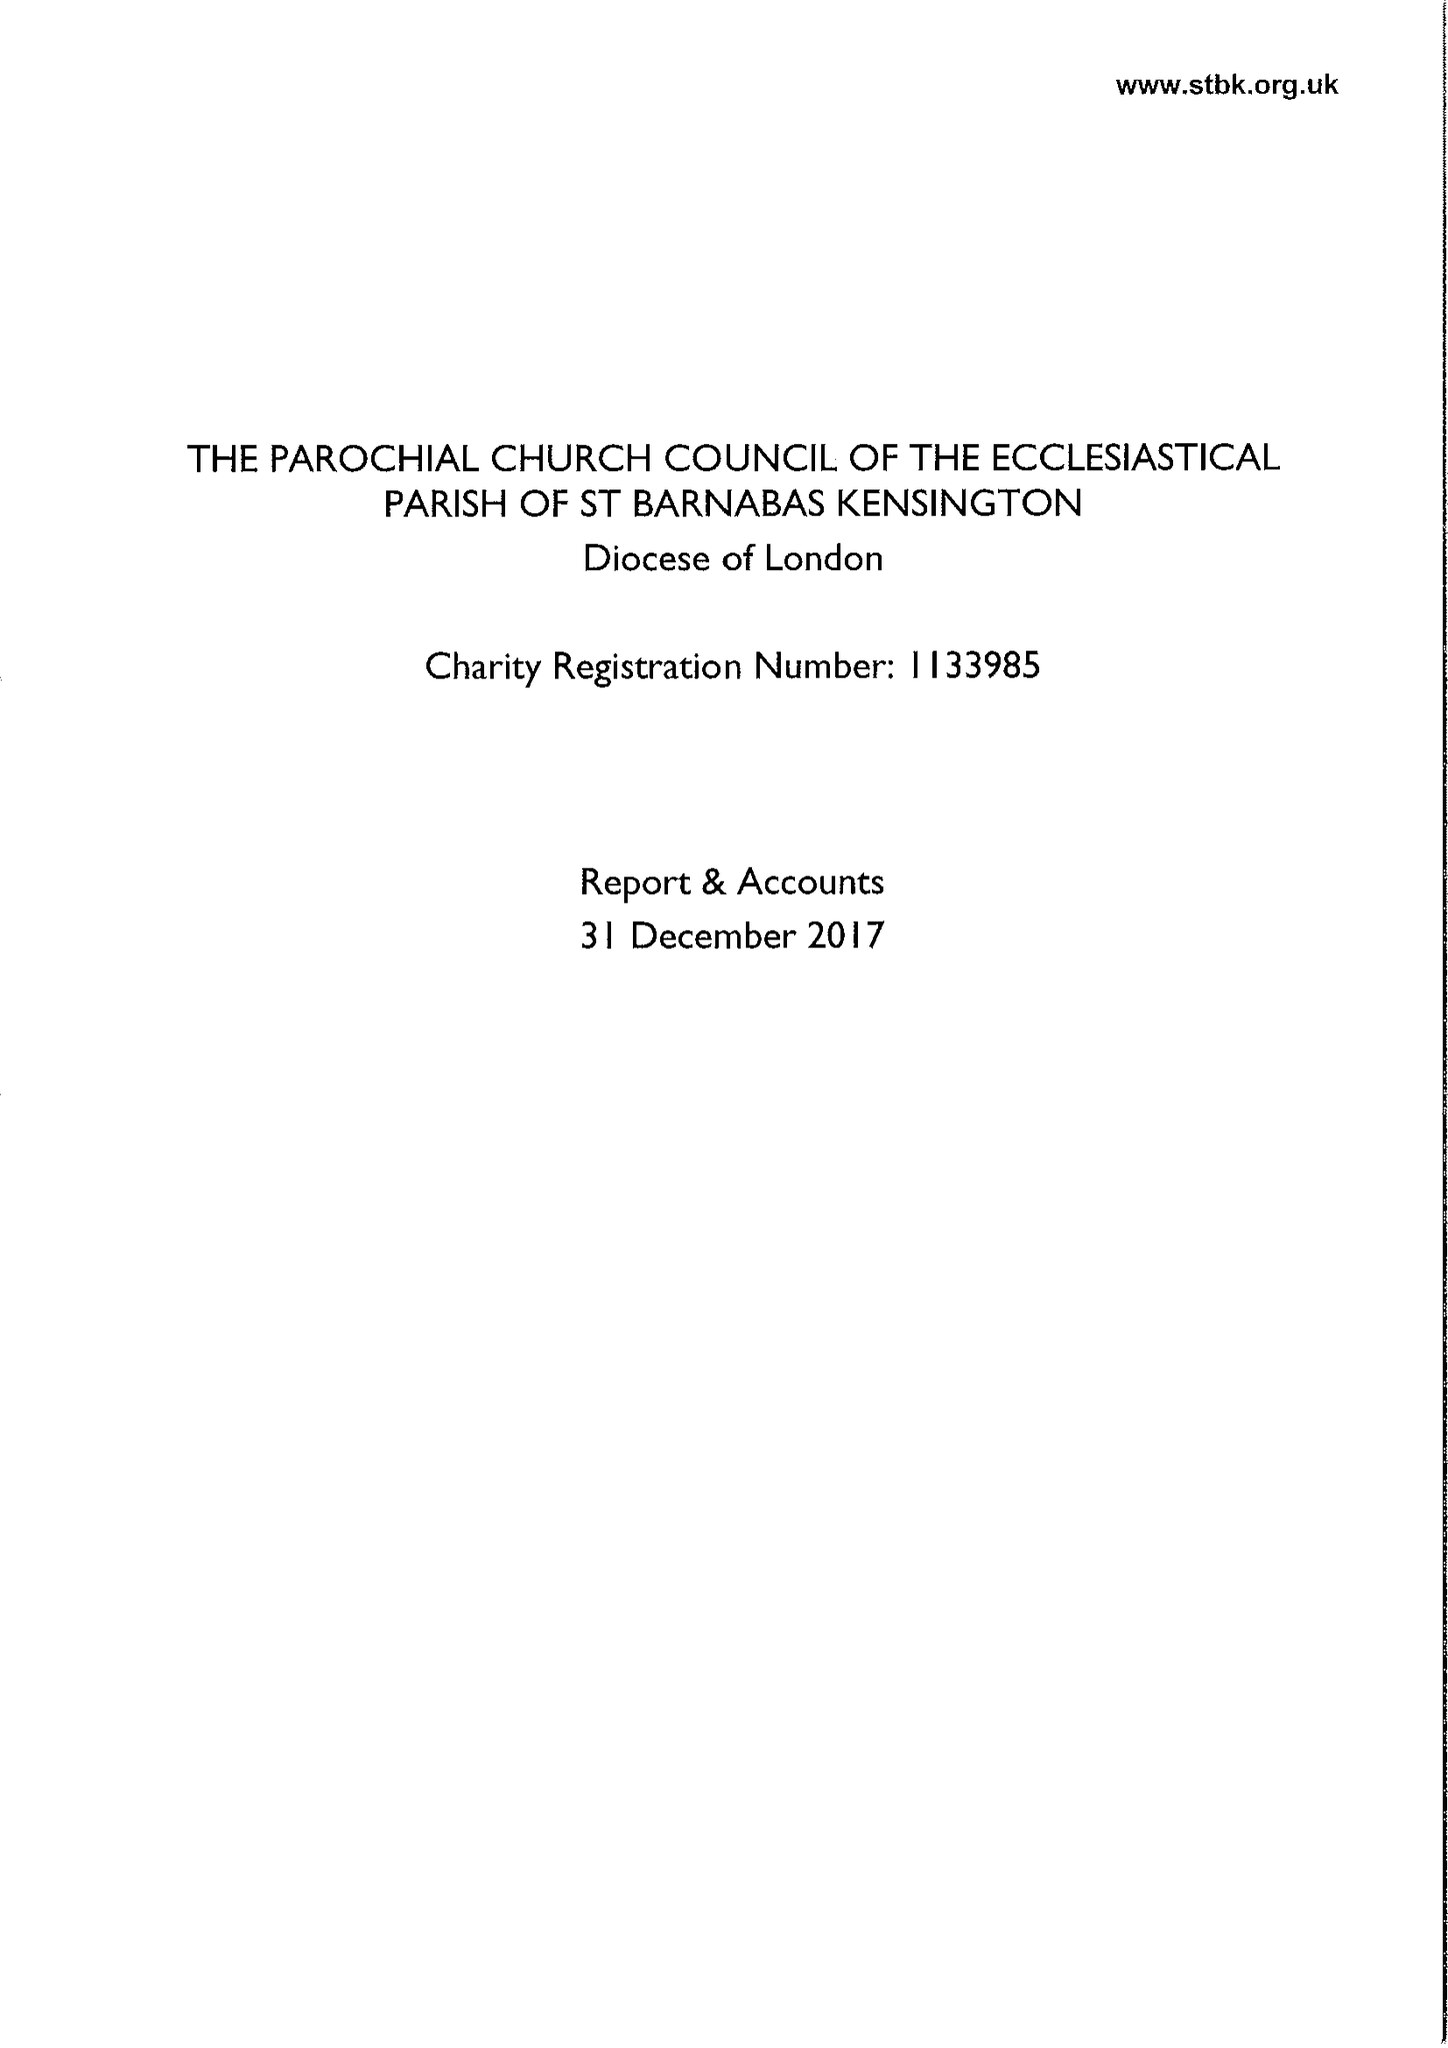What is the value for the spending_annually_in_british_pounds?
Answer the question using a single word or phrase. 517527.00 